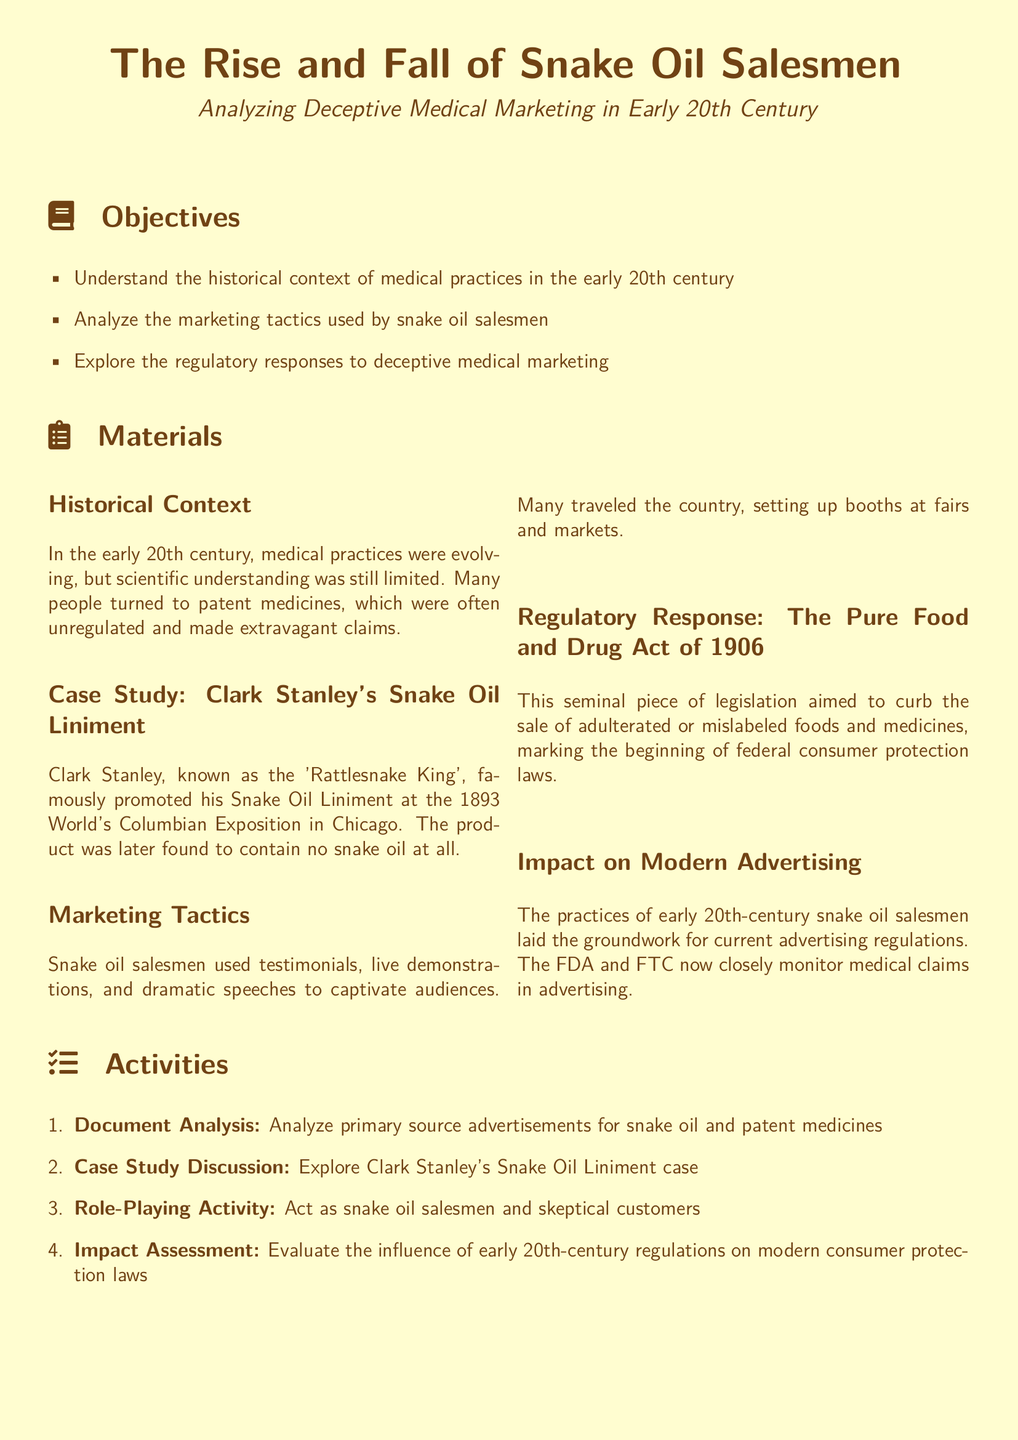what is the title of the lesson plan? The title of the lesson plan is the main heading found at the beginning of the document.
Answer: The Rise and Fall of Snake Oil Salesmen what year was the Pure Food and Drug Act enacted? The Pure Food and Drug Act is a significant regulatory response mentioned in the document and relates to the early 20th century.
Answer: 1906 who was known as the 'Rattlesnake King'? This nickname refers to the individual who promoted Snake Oil Liniment at the 1893 World's Columbian Exposition.
Answer: Clark Stanley what is one marketing tactic used by snake oil salesmen? The document lists specific methods used by snake oil salesmen to promote their products, one of which can be named.
Answer: Testimonials how many activities are listed in the document? The number of activities provided in the Activities section indicates the total planned activities for the lesson.
Answer: Four what is the purpose of the written reflection assessment? The document describes this assessment as focused on understanding the influence of past practices on current regulations.
Answer: Influence of early 20th-century medical marketing practices what does the lesson plan aim to teach about modern advertising? The document explicitly states a connection between historical practices and their impact on current advertising regulations.
Answer: Groundwork for current advertising regulations what section describes Clark Stanley's product at the 1893 exposition? This section includes relevant historical context about a notable snake oil salesman's promotional activities.
Answer: Case Study: Clark Stanley's Snake Oil Liniment 